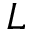<formula> <loc_0><loc_0><loc_500><loc_500>L</formula> 